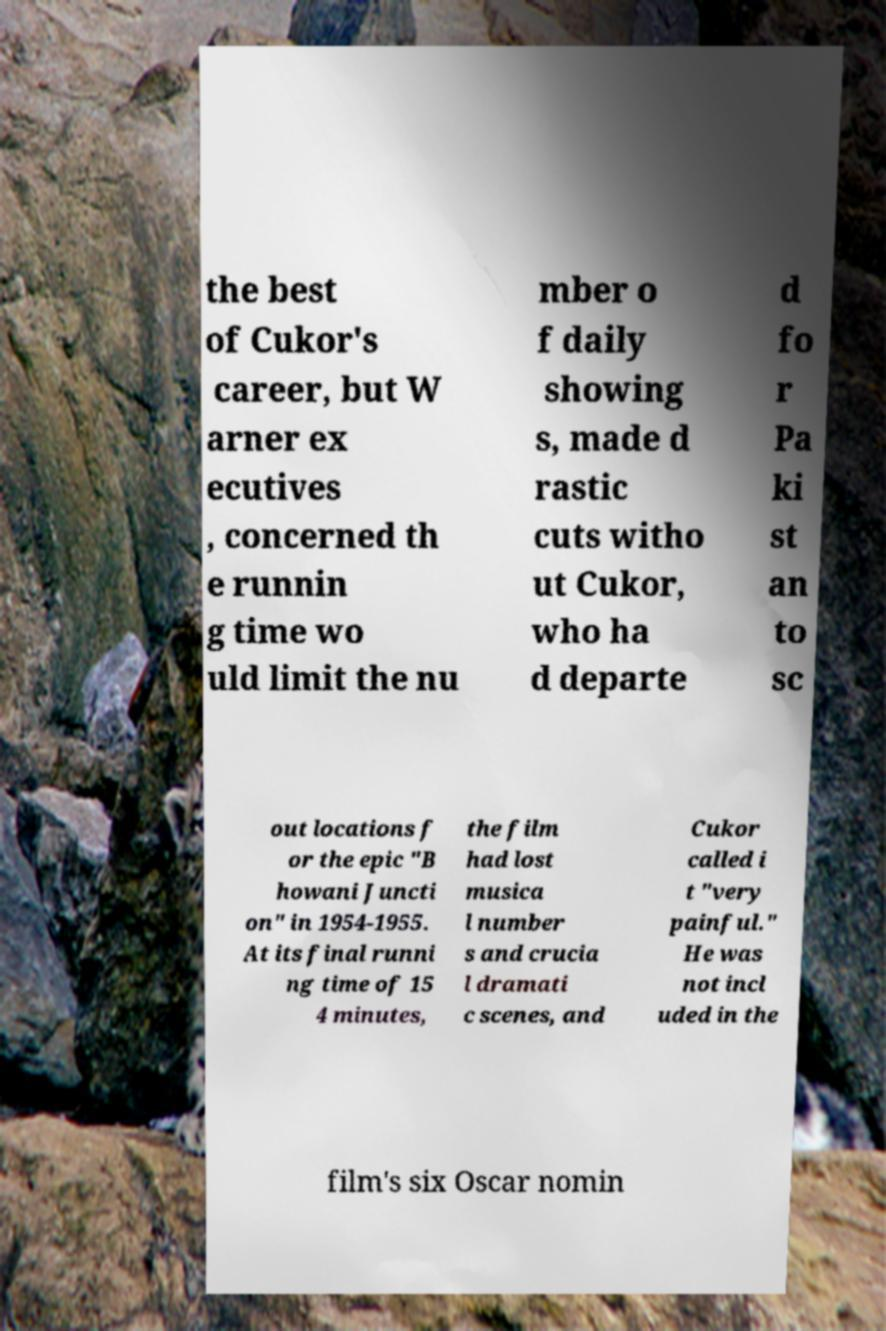There's text embedded in this image that I need extracted. Can you transcribe it verbatim? the best of Cukor's career, but W arner ex ecutives , concerned th e runnin g time wo uld limit the nu mber o f daily showing s, made d rastic cuts witho ut Cukor, who ha d departe d fo r Pa ki st an to sc out locations f or the epic "B howani Juncti on" in 1954-1955. At its final runni ng time of 15 4 minutes, the film had lost musica l number s and crucia l dramati c scenes, and Cukor called i t "very painful." He was not incl uded in the film's six Oscar nomin 